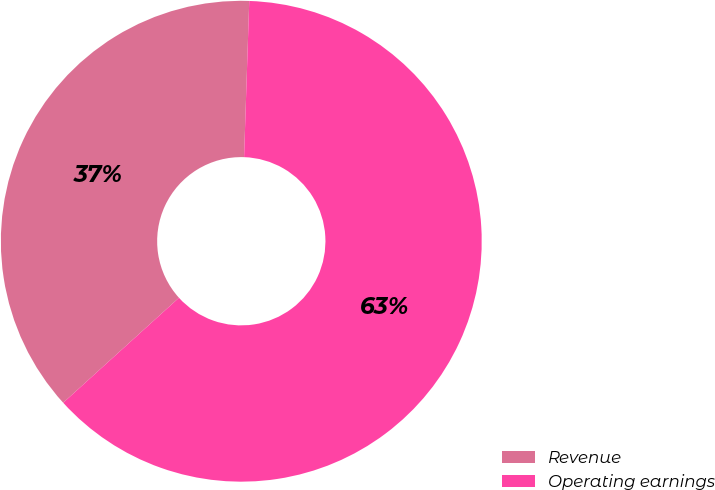Convert chart to OTSL. <chart><loc_0><loc_0><loc_500><loc_500><pie_chart><fcel>Revenue<fcel>Operating earnings<nl><fcel>37.25%<fcel>62.75%<nl></chart> 